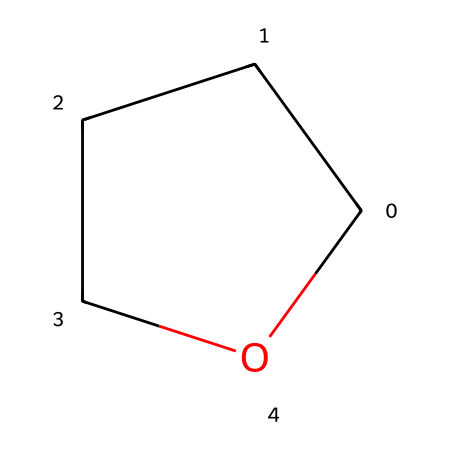What is the molecular formula of tetrahydrofuran? The SMILES representation "C1CCCO1" indicates that there are four carbon atoms, eight hydrogen atoms, and one oxygen atom present, which corresponds to the molecular formula C4H8O.
Answer: C4H8O How many carbon atoms are in this compound? Analyzing the SMILES notation reveals the presence of four carbon atoms, as each 'C' in the notation corresponds to a carbon atom.
Answer: four What type of chemical structure is tetrahydrofuran classified as? Since tetrahydrofuran contains an ether functional group characterized by an oxygen atom within a ring structure made from carbon atoms, it is classified as a cyclic ether.
Answer: cyclic ether What is the total number of atoms present in tetrahydrofuran? The chemical structure "C1CCCO1" has a total of four carbon atoms (C), eight hydrogen atoms (H), and one oxygen atom (O), resulting in a total of thirteen atoms combined.
Answer: thirteen What is the bond type between the oxygen and carbon atoms in tetrahydrofuran? In ether compounds such as tetrahydrofuran, the bond formed between the oxygen atom and the carbon atoms is classified as a covalent bond, due to the sharing of electrons.
Answer: covalent bond How many rings are present in the structure of tetrahydrofuran? The notation "C1CCCO1" indicates that there is a single ring structure, marked by corresponding numbers (1 in this case) that indicate the start and end of the ring.
Answer: one 